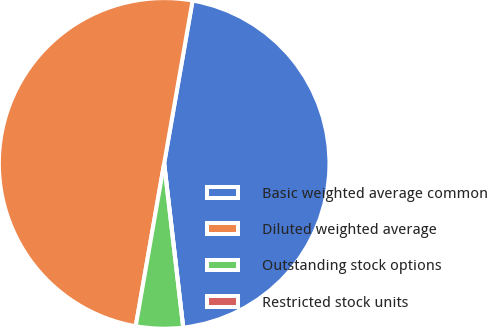Convert chart to OTSL. <chart><loc_0><loc_0><loc_500><loc_500><pie_chart><fcel>Basic weighted average common<fcel>Diluted weighted average<fcel>Outstanding stock options<fcel>Restricted stock units<nl><fcel>45.41%<fcel>50.0%<fcel>4.59%<fcel>0.0%<nl></chart> 